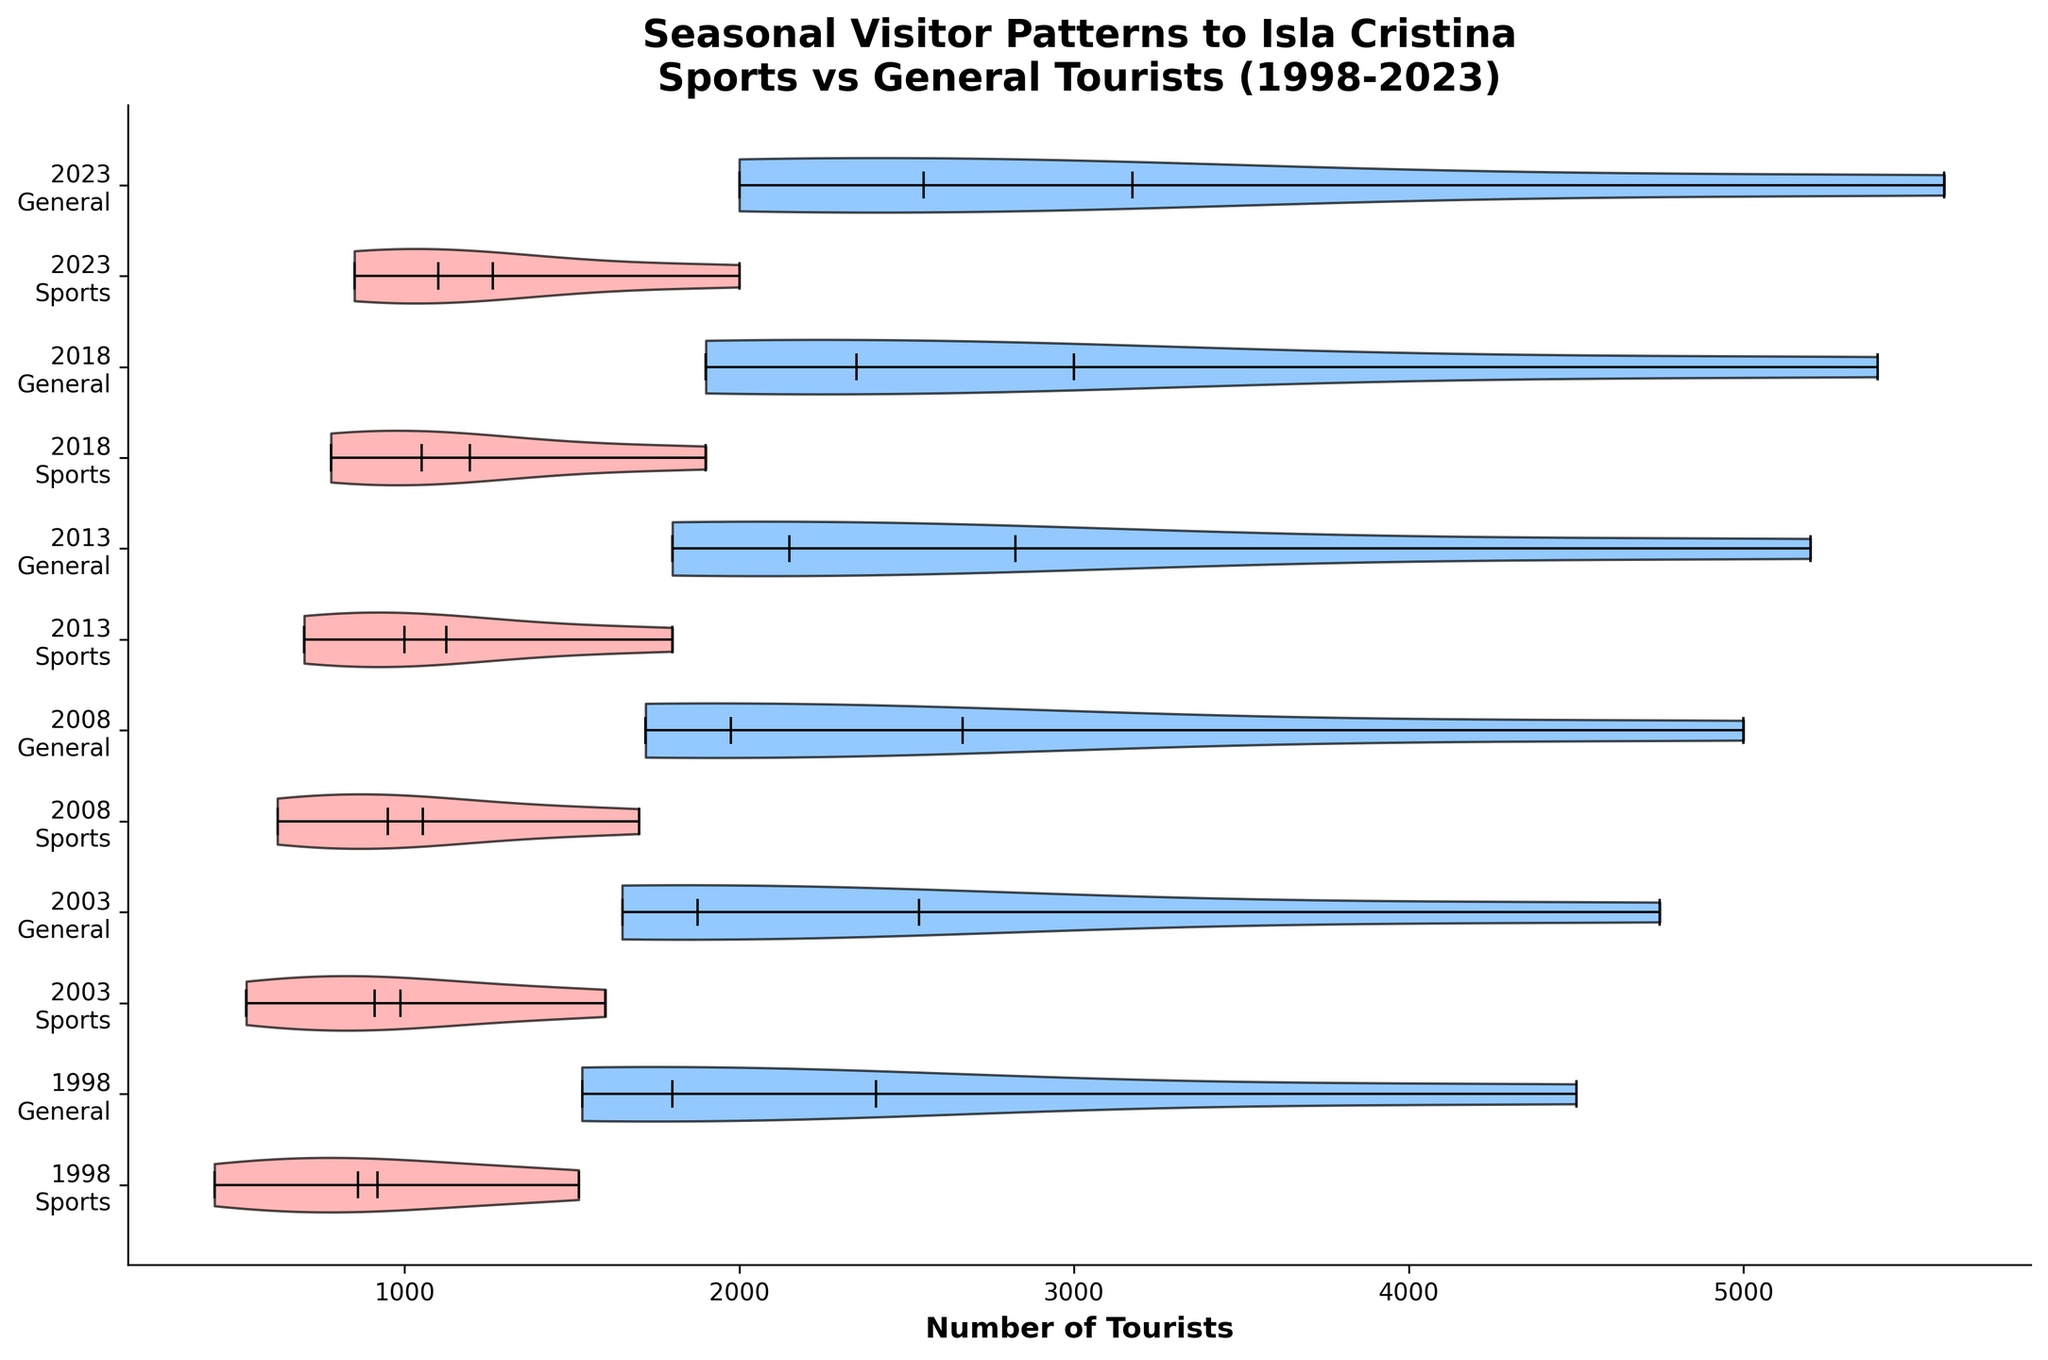What is the title of the chart? The title is usually placed at the top of the chart.
Answer: Seasonal Visitor Patterns to Isla Cristina Sports vs General Tourists (1998-2023) What are the labels on the x-axis? The x-axis labels are the number of tourists, shown along the bottom of the chart.
Answer: Number of Tourists What color represents Sports Tourists on the chart? The colors used are shown in the violins and usually described in the legend or by observation. Sports tourists are often marked with a unique color.
Answer: Red Which year and tourist type had the highest median number of tourists in July? Look for the highest median value among the July data points for both tourist types by observing the median lines in the violin plots.
Answer: 2023, General Tourists How does the number of sports tourists in January 2023 compare to those in January 1998? January data points for sports tourists in both years can be compared by the height or position of the violins on the x-axis. Calculate the difference between their medians if needed.
Answer: Higher in 2023 Which month shows the greatest increase in sports tourists from 1998 to 2023? Compare the violins corresponding to sports tourists across years within each month. The month with the biggest vertical increase is the answer.
Answer: July How do the distributions of general tourists in 2008 compare to those in 2018? Look at the shape, spread, and center of the violin plots for general tourists in these two years. Compare the medians, means, and range of the data.
Answer: Higher in 2018 In which year was the difference between sports and general tourists the smallest in April? Compare the horizontal distance (gap) between the sports and general tourists' medians in April for each year. Identify the smallest gap.
Answer: 1998 What is the general trend for sports tourists over the years? Assess the change in the median positions of the sports tourists' violins over time. Determine if there is an increasing or decreasing trend.
Answer: Increasing Which year had the most balanced number of sports and general tourists in October? Find the year where the medians for sports and general tourists in October are closest in value.
Answer: 2018 